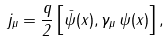<formula> <loc_0><loc_0><loc_500><loc_500>j _ { \mu } = \frac { q } { 2 } \left [ \bar { \psi } ( x ) , \gamma _ { \mu } \, \psi ( x ) \right ] ,</formula> 